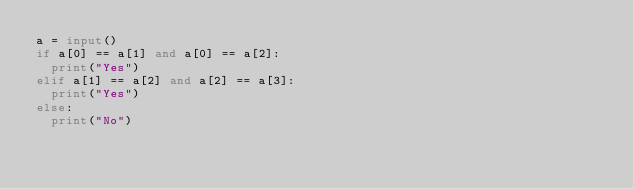Convert code to text. <code><loc_0><loc_0><loc_500><loc_500><_Python_>a = input()
if a[0] == a[1] and a[0] == a[2]:
  print("Yes")
elif a[1] == a[2] and a[2] == a[3]:
  print("Yes")
else:
  print("No")</code> 